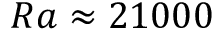Convert formula to latex. <formula><loc_0><loc_0><loc_500><loc_500>R a \approx 2 1 0 0 0</formula> 